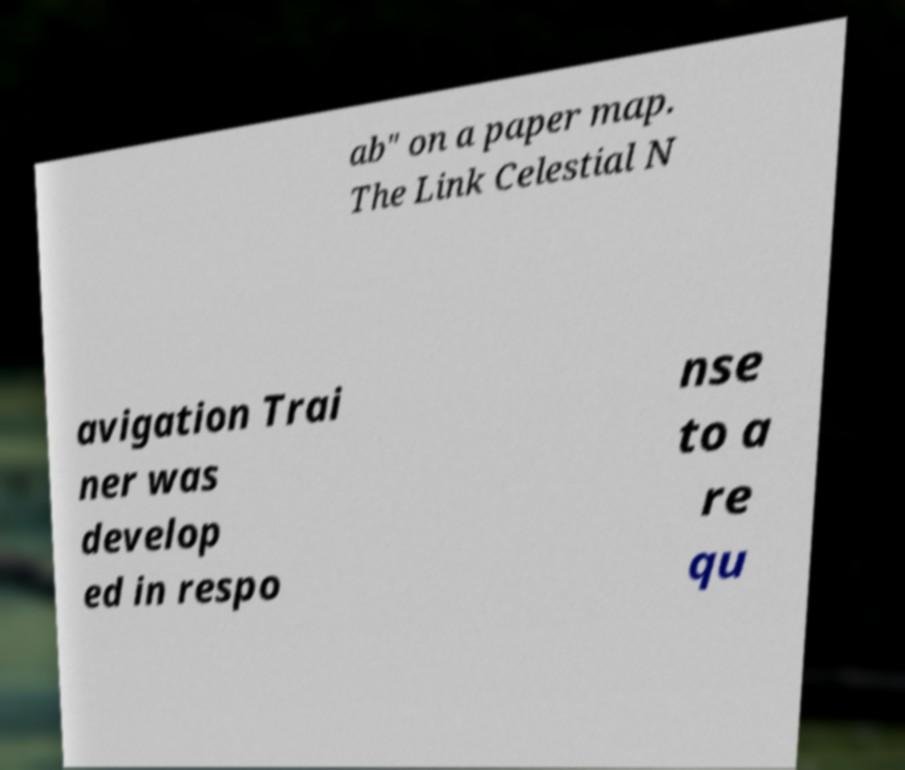For documentation purposes, I need the text within this image transcribed. Could you provide that? ab" on a paper map. The Link Celestial N avigation Trai ner was develop ed in respo nse to a re qu 